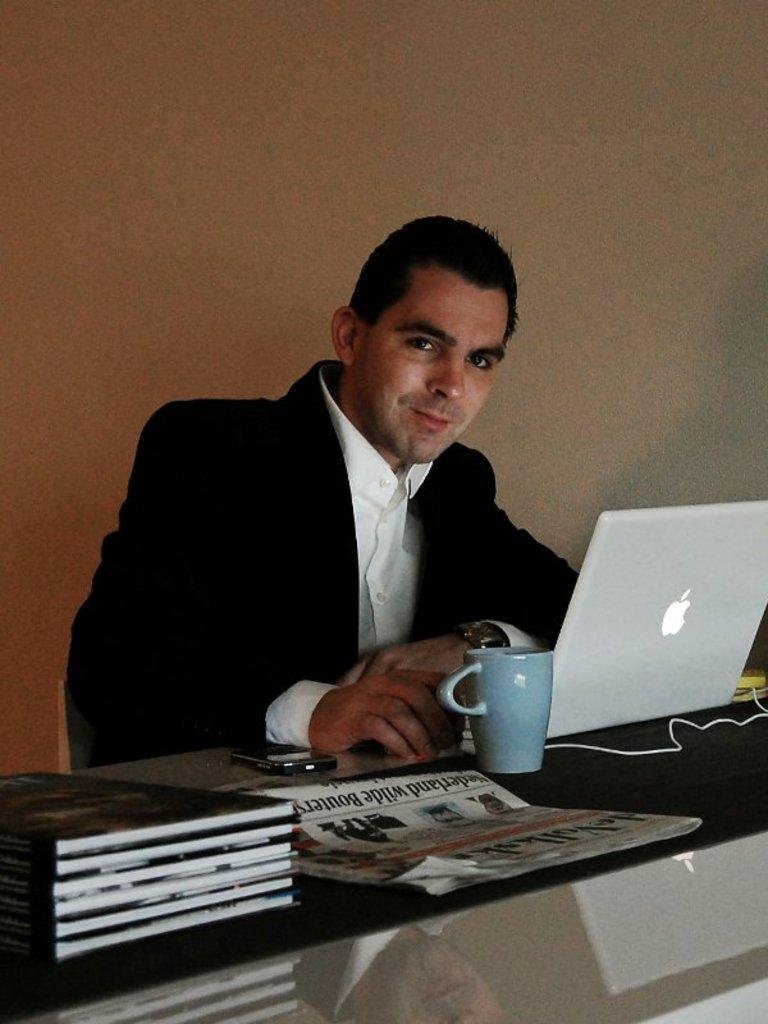What is the man in the image doing? The man is sitting in the image. What is in front of the man? The man has a table in front of him. What items can be seen on the table? There are books, a coffee mug, a laptop, a newspaper, and a smartphone on the table. What type of ray is visible in the image? There is no ray present in the image. What does the man need to cover the table in the image? The man does not need anything to cover the table in the image, as it is already covered by the items mentioned in the facts. 